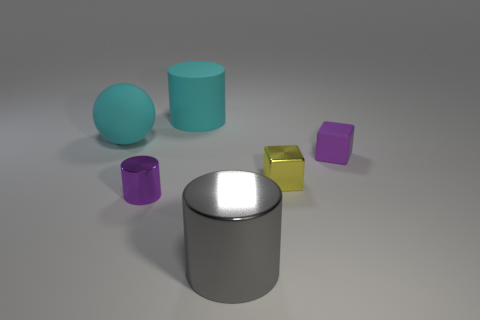Is the size of the yellow shiny block the same as the cyan cylinder?
Ensure brevity in your answer.  No. There is a large cylinder behind the small purple block; what is its material?
Your answer should be compact. Rubber. Are there fewer big cyan rubber cylinders right of the large metallic cylinder than small cyan cubes?
Give a very brief answer. No. Do the tiny purple metal object and the big gray thing have the same shape?
Provide a succinct answer. Yes. Is there any other thing that is the same shape as the big metallic thing?
Offer a terse response. Yes. Is there a big gray shiny cube?
Keep it short and to the point. No. Is the shape of the small yellow thing the same as the tiny purple thing that is on the right side of the large matte cylinder?
Provide a succinct answer. Yes. The big cyan object that is left of the purple object to the left of the purple block is made of what material?
Your answer should be very brief. Rubber. What color is the tiny cylinder?
Make the answer very short. Purple. There is a cylinder that is behind the purple shiny cylinder; is it the same color as the big matte object to the left of the tiny cylinder?
Ensure brevity in your answer.  Yes. 